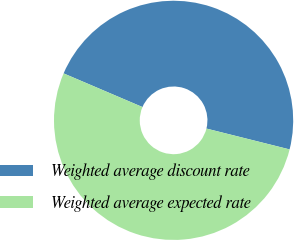<chart> <loc_0><loc_0><loc_500><loc_500><pie_chart><fcel>Weighted average discount rate<fcel>Weighted average expected rate<nl><fcel>47.49%<fcel>52.51%<nl></chart> 